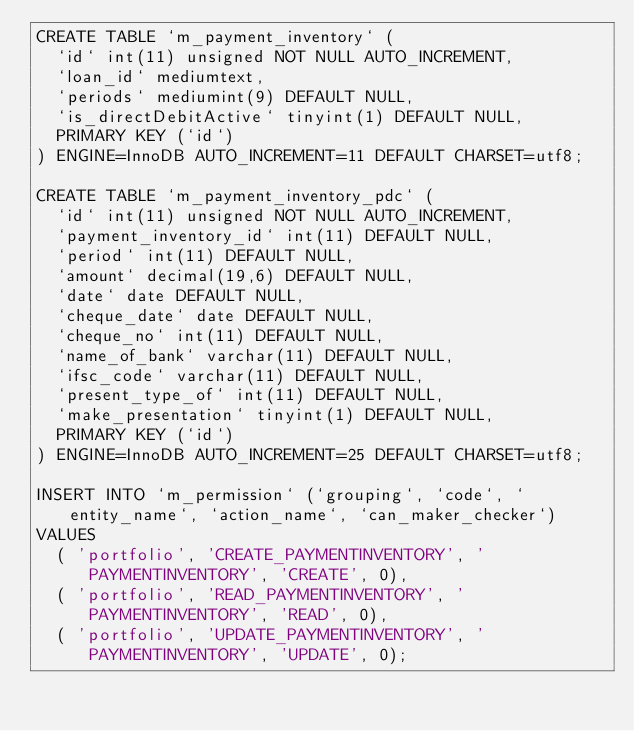Convert code to text. <code><loc_0><loc_0><loc_500><loc_500><_SQL_>CREATE TABLE `m_payment_inventory` (
  `id` int(11) unsigned NOT NULL AUTO_INCREMENT,
  `loan_id` mediumtext,
  `periods` mediumint(9) DEFAULT NULL,
  `is_directDebitActive` tinyint(1) DEFAULT NULL,
  PRIMARY KEY (`id`)
) ENGINE=InnoDB AUTO_INCREMENT=11 DEFAULT CHARSET=utf8;

CREATE TABLE `m_payment_inventory_pdc` (
  `id` int(11) unsigned NOT NULL AUTO_INCREMENT,
  `payment_inventory_id` int(11) DEFAULT NULL,
  `period` int(11) DEFAULT NULL,
  `amount` decimal(19,6) DEFAULT NULL,
  `date` date DEFAULT NULL,
  `cheque_date` date DEFAULT NULL,
  `cheque_no` int(11) DEFAULT NULL,
  `name_of_bank` varchar(11) DEFAULT NULL,
  `ifsc_code` varchar(11) DEFAULT NULL,
  `present_type_of` int(11) DEFAULT NULL,
  `make_presentation` tinyint(1) DEFAULT NULL,
  PRIMARY KEY (`id`)
) ENGINE=InnoDB AUTO_INCREMENT=25 DEFAULT CHARSET=utf8;

INSERT INTO `m_permission` (`grouping`, `code`, `entity_name`, `action_name`, `can_maker_checker`)
VALUES
	( 'portfolio', 'CREATE_PAYMENTINVENTORY', 'PAYMENTINVENTORY', 'CREATE', 0),
	( 'portfolio', 'READ_PAYMENTINVENTORY', 'PAYMENTINVENTORY', 'READ', 0),
	( 'portfolio', 'UPDATE_PAYMENTINVENTORY', 'PAYMENTINVENTORY', 'UPDATE', 0);
	
	
	
</code> 